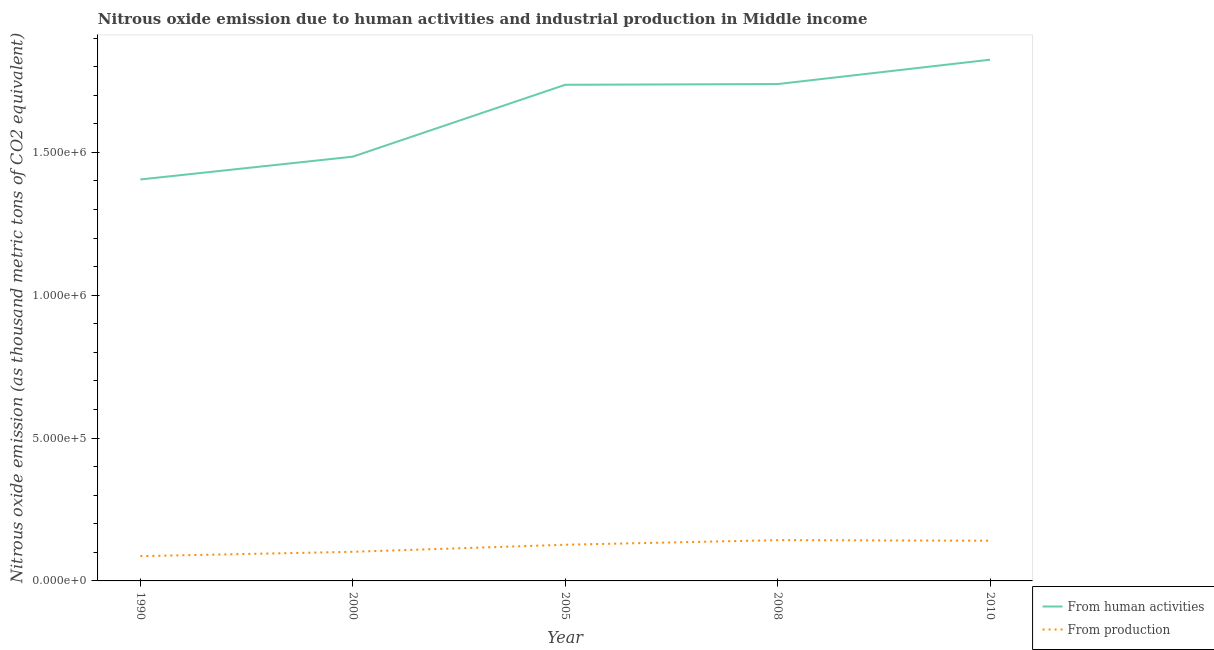How many different coloured lines are there?
Your answer should be very brief. 2. Does the line corresponding to amount of emissions generated from industries intersect with the line corresponding to amount of emissions from human activities?
Give a very brief answer. No. Is the number of lines equal to the number of legend labels?
Offer a terse response. Yes. What is the amount of emissions from human activities in 2008?
Your answer should be compact. 1.74e+06. Across all years, what is the maximum amount of emissions generated from industries?
Keep it short and to the point. 1.43e+05. Across all years, what is the minimum amount of emissions from human activities?
Offer a very short reply. 1.41e+06. What is the total amount of emissions generated from industries in the graph?
Make the answer very short. 5.99e+05. What is the difference between the amount of emissions generated from industries in 1990 and that in 2008?
Your answer should be very brief. -5.59e+04. What is the difference between the amount of emissions generated from industries in 2005 and the amount of emissions from human activities in 1990?
Ensure brevity in your answer.  -1.28e+06. What is the average amount of emissions generated from industries per year?
Give a very brief answer. 1.20e+05. In the year 1990, what is the difference between the amount of emissions from human activities and amount of emissions generated from industries?
Keep it short and to the point. 1.32e+06. In how many years, is the amount of emissions generated from industries greater than 300000 thousand metric tons?
Ensure brevity in your answer.  0. What is the ratio of the amount of emissions from human activities in 1990 to that in 2008?
Give a very brief answer. 0.81. What is the difference between the highest and the second highest amount of emissions generated from industries?
Offer a very short reply. 1986.4. What is the difference between the highest and the lowest amount of emissions from human activities?
Your answer should be compact. 4.19e+05. How many lines are there?
Keep it short and to the point. 2. Are the values on the major ticks of Y-axis written in scientific E-notation?
Provide a succinct answer. Yes. Does the graph contain grids?
Your response must be concise. No. How many legend labels are there?
Your response must be concise. 2. How are the legend labels stacked?
Your answer should be very brief. Vertical. What is the title of the graph?
Offer a very short reply. Nitrous oxide emission due to human activities and industrial production in Middle income. Does "Death rate" appear as one of the legend labels in the graph?
Make the answer very short. No. What is the label or title of the X-axis?
Provide a short and direct response. Year. What is the label or title of the Y-axis?
Your response must be concise. Nitrous oxide emission (as thousand metric tons of CO2 equivalent). What is the Nitrous oxide emission (as thousand metric tons of CO2 equivalent) in From human activities in 1990?
Provide a short and direct response. 1.41e+06. What is the Nitrous oxide emission (as thousand metric tons of CO2 equivalent) of From production in 1990?
Offer a terse response. 8.68e+04. What is the Nitrous oxide emission (as thousand metric tons of CO2 equivalent) of From human activities in 2000?
Provide a short and direct response. 1.49e+06. What is the Nitrous oxide emission (as thousand metric tons of CO2 equivalent) of From production in 2000?
Offer a very short reply. 1.02e+05. What is the Nitrous oxide emission (as thousand metric tons of CO2 equivalent) of From human activities in 2005?
Keep it short and to the point. 1.74e+06. What is the Nitrous oxide emission (as thousand metric tons of CO2 equivalent) in From production in 2005?
Your answer should be very brief. 1.27e+05. What is the Nitrous oxide emission (as thousand metric tons of CO2 equivalent) in From human activities in 2008?
Offer a very short reply. 1.74e+06. What is the Nitrous oxide emission (as thousand metric tons of CO2 equivalent) in From production in 2008?
Your response must be concise. 1.43e+05. What is the Nitrous oxide emission (as thousand metric tons of CO2 equivalent) in From human activities in 2010?
Give a very brief answer. 1.82e+06. What is the Nitrous oxide emission (as thousand metric tons of CO2 equivalent) of From production in 2010?
Provide a short and direct response. 1.41e+05. Across all years, what is the maximum Nitrous oxide emission (as thousand metric tons of CO2 equivalent) in From human activities?
Your answer should be very brief. 1.82e+06. Across all years, what is the maximum Nitrous oxide emission (as thousand metric tons of CO2 equivalent) of From production?
Your answer should be compact. 1.43e+05. Across all years, what is the minimum Nitrous oxide emission (as thousand metric tons of CO2 equivalent) of From human activities?
Your answer should be very brief. 1.41e+06. Across all years, what is the minimum Nitrous oxide emission (as thousand metric tons of CO2 equivalent) in From production?
Offer a terse response. 8.68e+04. What is the total Nitrous oxide emission (as thousand metric tons of CO2 equivalent) in From human activities in the graph?
Give a very brief answer. 8.19e+06. What is the total Nitrous oxide emission (as thousand metric tons of CO2 equivalent) of From production in the graph?
Ensure brevity in your answer.  5.99e+05. What is the difference between the Nitrous oxide emission (as thousand metric tons of CO2 equivalent) in From human activities in 1990 and that in 2000?
Give a very brief answer. -7.98e+04. What is the difference between the Nitrous oxide emission (as thousand metric tons of CO2 equivalent) of From production in 1990 and that in 2000?
Offer a very short reply. -1.52e+04. What is the difference between the Nitrous oxide emission (as thousand metric tons of CO2 equivalent) of From human activities in 1990 and that in 2005?
Your answer should be very brief. -3.31e+05. What is the difference between the Nitrous oxide emission (as thousand metric tons of CO2 equivalent) of From production in 1990 and that in 2005?
Your answer should be very brief. -3.98e+04. What is the difference between the Nitrous oxide emission (as thousand metric tons of CO2 equivalent) of From human activities in 1990 and that in 2008?
Offer a very short reply. -3.34e+05. What is the difference between the Nitrous oxide emission (as thousand metric tons of CO2 equivalent) of From production in 1990 and that in 2008?
Your answer should be very brief. -5.59e+04. What is the difference between the Nitrous oxide emission (as thousand metric tons of CO2 equivalent) of From human activities in 1990 and that in 2010?
Offer a very short reply. -4.19e+05. What is the difference between the Nitrous oxide emission (as thousand metric tons of CO2 equivalent) in From production in 1990 and that in 2010?
Provide a succinct answer. -5.40e+04. What is the difference between the Nitrous oxide emission (as thousand metric tons of CO2 equivalent) of From human activities in 2000 and that in 2005?
Give a very brief answer. -2.52e+05. What is the difference between the Nitrous oxide emission (as thousand metric tons of CO2 equivalent) in From production in 2000 and that in 2005?
Ensure brevity in your answer.  -2.47e+04. What is the difference between the Nitrous oxide emission (as thousand metric tons of CO2 equivalent) in From human activities in 2000 and that in 2008?
Offer a terse response. -2.54e+05. What is the difference between the Nitrous oxide emission (as thousand metric tons of CO2 equivalent) in From production in 2000 and that in 2008?
Keep it short and to the point. -4.08e+04. What is the difference between the Nitrous oxide emission (as thousand metric tons of CO2 equivalent) in From human activities in 2000 and that in 2010?
Make the answer very short. -3.39e+05. What is the difference between the Nitrous oxide emission (as thousand metric tons of CO2 equivalent) in From production in 2000 and that in 2010?
Offer a very short reply. -3.88e+04. What is the difference between the Nitrous oxide emission (as thousand metric tons of CO2 equivalent) in From human activities in 2005 and that in 2008?
Provide a short and direct response. -2525.2. What is the difference between the Nitrous oxide emission (as thousand metric tons of CO2 equivalent) of From production in 2005 and that in 2008?
Provide a short and direct response. -1.61e+04. What is the difference between the Nitrous oxide emission (as thousand metric tons of CO2 equivalent) of From human activities in 2005 and that in 2010?
Provide a short and direct response. -8.78e+04. What is the difference between the Nitrous oxide emission (as thousand metric tons of CO2 equivalent) in From production in 2005 and that in 2010?
Your answer should be compact. -1.41e+04. What is the difference between the Nitrous oxide emission (as thousand metric tons of CO2 equivalent) in From human activities in 2008 and that in 2010?
Your response must be concise. -8.53e+04. What is the difference between the Nitrous oxide emission (as thousand metric tons of CO2 equivalent) of From production in 2008 and that in 2010?
Provide a succinct answer. 1986.4. What is the difference between the Nitrous oxide emission (as thousand metric tons of CO2 equivalent) of From human activities in 1990 and the Nitrous oxide emission (as thousand metric tons of CO2 equivalent) of From production in 2000?
Your response must be concise. 1.30e+06. What is the difference between the Nitrous oxide emission (as thousand metric tons of CO2 equivalent) of From human activities in 1990 and the Nitrous oxide emission (as thousand metric tons of CO2 equivalent) of From production in 2005?
Your response must be concise. 1.28e+06. What is the difference between the Nitrous oxide emission (as thousand metric tons of CO2 equivalent) of From human activities in 1990 and the Nitrous oxide emission (as thousand metric tons of CO2 equivalent) of From production in 2008?
Provide a short and direct response. 1.26e+06. What is the difference between the Nitrous oxide emission (as thousand metric tons of CO2 equivalent) in From human activities in 1990 and the Nitrous oxide emission (as thousand metric tons of CO2 equivalent) in From production in 2010?
Offer a terse response. 1.26e+06. What is the difference between the Nitrous oxide emission (as thousand metric tons of CO2 equivalent) of From human activities in 2000 and the Nitrous oxide emission (as thousand metric tons of CO2 equivalent) of From production in 2005?
Provide a succinct answer. 1.36e+06. What is the difference between the Nitrous oxide emission (as thousand metric tons of CO2 equivalent) of From human activities in 2000 and the Nitrous oxide emission (as thousand metric tons of CO2 equivalent) of From production in 2008?
Give a very brief answer. 1.34e+06. What is the difference between the Nitrous oxide emission (as thousand metric tons of CO2 equivalent) of From human activities in 2000 and the Nitrous oxide emission (as thousand metric tons of CO2 equivalent) of From production in 2010?
Provide a short and direct response. 1.34e+06. What is the difference between the Nitrous oxide emission (as thousand metric tons of CO2 equivalent) of From human activities in 2005 and the Nitrous oxide emission (as thousand metric tons of CO2 equivalent) of From production in 2008?
Keep it short and to the point. 1.59e+06. What is the difference between the Nitrous oxide emission (as thousand metric tons of CO2 equivalent) in From human activities in 2005 and the Nitrous oxide emission (as thousand metric tons of CO2 equivalent) in From production in 2010?
Give a very brief answer. 1.60e+06. What is the difference between the Nitrous oxide emission (as thousand metric tons of CO2 equivalent) in From human activities in 2008 and the Nitrous oxide emission (as thousand metric tons of CO2 equivalent) in From production in 2010?
Offer a terse response. 1.60e+06. What is the average Nitrous oxide emission (as thousand metric tons of CO2 equivalent) of From human activities per year?
Offer a terse response. 1.64e+06. What is the average Nitrous oxide emission (as thousand metric tons of CO2 equivalent) of From production per year?
Your response must be concise. 1.20e+05. In the year 1990, what is the difference between the Nitrous oxide emission (as thousand metric tons of CO2 equivalent) of From human activities and Nitrous oxide emission (as thousand metric tons of CO2 equivalent) of From production?
Your response must be concise. 1.32e+06. In the year 2000, what is the difference between the Nitrous oxide emission (as thousand metric tons of CO2 equivalent) of From human activities and Nitrous oxide emission (as thousand metric tons of CO2 equivalent) of From production?
Your answer should be very brief. 1.38e+06. In the year 2005, what is the difference between the Nitrous oxide emission (as thousand metric tons of CO2 equivalent) of From human activities and Nitrous oxide emission (as thousand metric tons of CO2 equivalent) of From production?
Offer a terse response. 1.61e+06. In the year 2008, what is the difference between the Nitrous oxide emission (as thousand metric tons of CO2 equivalent) in From human activities and Nitrous oxide emission (as thousand metric tons of CO2 equivalent) in From production?
Provide a succinct answer. 1.60e+06. In the year 2010, what is the difference between the Nitrous oxide emission (as thousand metric tons of CO2 equivalent) of From human activities and Nitrous oxide emission (as thousand metric tons of CO2 equivalent) of From production?
Keep it short and to the point. 1.68e+06. What is the ratio of the Nitrous oxide emission (as thousand metric tons of CO2 equivalent) of From human activities in 1990 to that in 2000?
Keep it short and to the point. 0.95. What is the ratio of the Nitrous oxide emission (as thousand metric tons of CO2 equivalent) in From production in 1990 to that in 2000?
Make the answer very short. 0.85. What is the ratio of the Nitrous oxide emission (as thousand metric tons of CO2 equivalent) in From human activities in 1990 to that in 2005?
Keep it short and to the point. 0.81. What is the ratio of the Nitrous oxide emission (as thousand metric tons of CO2 equivalent) of From production in 1990 to that in 2005?
Your answer should be compact. 0.69. What is the ratio of the Nitrous oxide emission (as thousand metric tons of CO2 equivalent) in From human activities in 1990 to that in 2008?
Make the answer very short. 0.81. What is the ratio of the Nitrous oxide emission (as thousand metric tons of CO2 equivalent) of From production in 1990 to that in 2008?
Your answer should be very brief. 0.61. What is the ratio of the Nitrous oxide emission (as thousand metric tons of CO2 equivalent) in From human activities in 1990 to that in 2010?
Your response must be concise. 0.77. What is the ratio of the Nitrous oxide emission (as thousand metric tons of CO2 equivalent) of From production in 1990 to that in 2010?
Give a very brief answer. 0.62. What is the ratio of the Nitrous oxide emission (as thousand metric tons of CO2 equivalent) of From human activities in 2000 to that in 2005?
Offer a terse response. 0.86. What is the ratio of the Nitrous oxide emission (as thousand metric tons of CO2 equivalent) of From production in 2000 to that in 2005?
Your response must be concise. 0.81. What is the ratio of the Nitrous oxide emission (as thousand metric tons of CO2 equivalent) of From human activities in 2000 to that in 2008?
Provide a short and direct response. 0.85. What is the ratio of the Nitrous oxide emission (as thousand metric tons of CO2 equivalent) in From production in 2000 to that in 2008?
Your answer should be compact. 0.71. What is the ratio of the Nitrous oxide emission (as thousand metric tons of CO2 equivalent) of From human activities in 2000 to that in 2010?
Offer a very short reply. 0.81. What is the ratio of the Nitrous oxide emission (as thousand metric tons of CO2 equivalent) of From production in 2000 to that in 2010?
Your answer should be very brief. 0.72. What is the ratio of the Nitrous oxide emission (as thousand metric tons of CO2 equivalent) of From human activities in 2005 to that in 2008?
Provide a succinct answer. 1. What is the ratio of the Nitrous oxide emission (as thousand metric tons of CO2 equivalent) in From production in 2005 to that in 2008?
Your response must be concise. 0.89. What is the ratio of the Nitrous oxide emission (as thousand metric tons of CO2 equivalent) in From human activities in 2005 to that in 2010?
Your answer should be compact. 0.95. What is the ratio of the Nitrous oxide emission (as thousand metric tons of CO2 equivalent) in From production in 2005 to that in 2010?
Your answer should be very brief. 0.9. What is the ratio of the Nitrous oxide emission (as thousand metric tons of CO2 equivalent) in From human activities in 2008 to that in 2010?
Keep it short and to the point. 0.95. What is the ratio of the Nitrous oxide emission (as thousand metric tons of CO2 equivalent) of From production in 2008 to that in 2010?
Provide a short and direct response. 1.01. What is the difference between the highest and the second highest Nitrous oxide emission (as thousand metric tons of CO2 equivalent) in From human activities?
Offer a very short reply. 8.53e+04. What is the difference between the highest and the second highest Nitrous oxide emission (as thousand metric tons of CO2 equivalent) of From production?
Offer a terse response. 1986.4. What is the difference between the highest and the lowest Nitrous oxide emission (as thousand metric tons of CO2 equivalent) of From human activities?
Keep it short and to the point. 4.19e+05. What is the difference between the highest and the lowest Nitrous oxide emission (as thousand metric tons of CO2 equivalent) in From production?
Your answer should be very brief. 5.59e+04. 